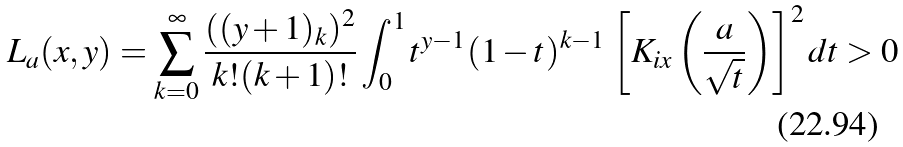<formula> <loc_0><loc_0><loc_500><loc_500>L _ { a } ( x , y ) = \sum _ { k = 0 } ^ { \infty } \frac { ( ( y + 1 ) _ { k } ) ^ { 2 } } { k ! ( k + 1 ) ! } \int _ { 0 } ^ { 1 } t ^ { y - 1 } ( 1 - t ) ^ { k - 1 } \, \left [ K _ { i x } \left ( \frac { a } { \sqrt { t } } \right ) \right ] ^ { 2 } d t > 0</formula> 